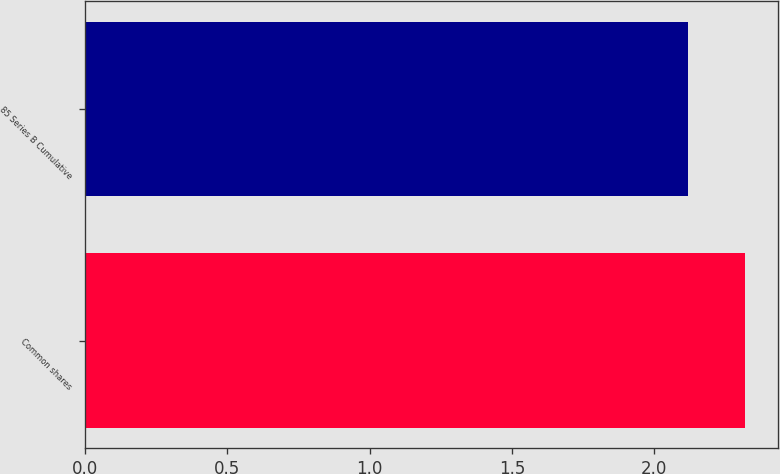<chart> <loc_0><loc_0><loc_500><loc_500><bar_chart><fcel>Common shares<fcel>85 Series B Cumulative<nl><fcel>2.32<fcel>2.12<nl></chart> 